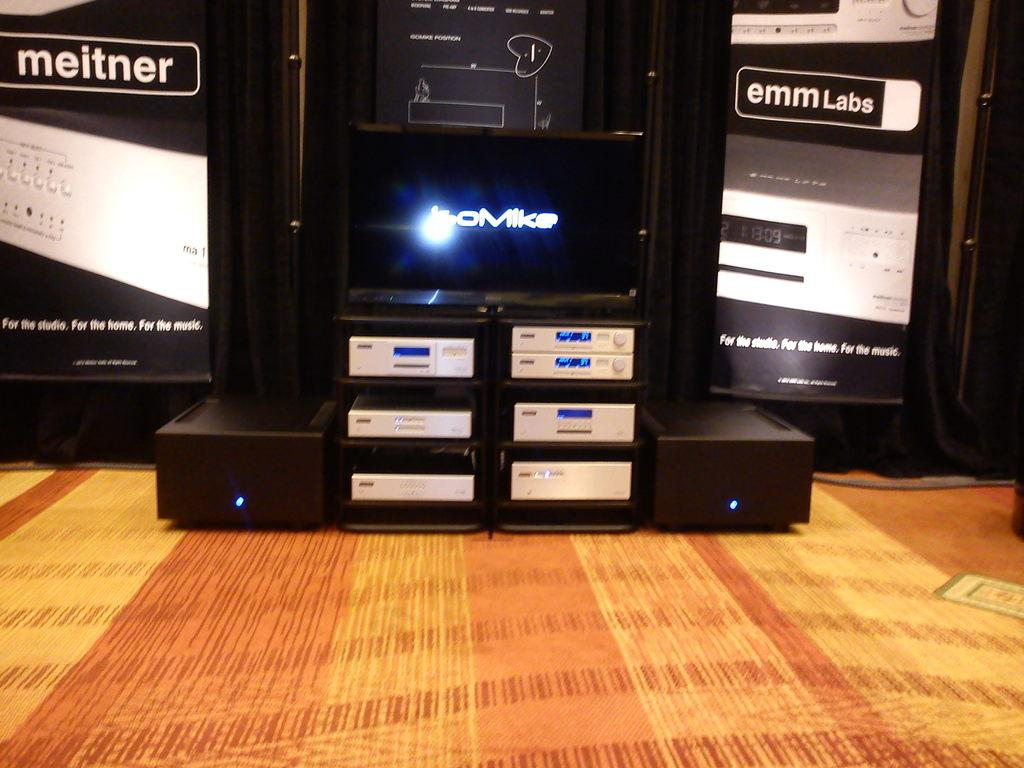<image>
Render a clear and concise summary of the photo. An emmLabs entertainment system is set up under a television. 